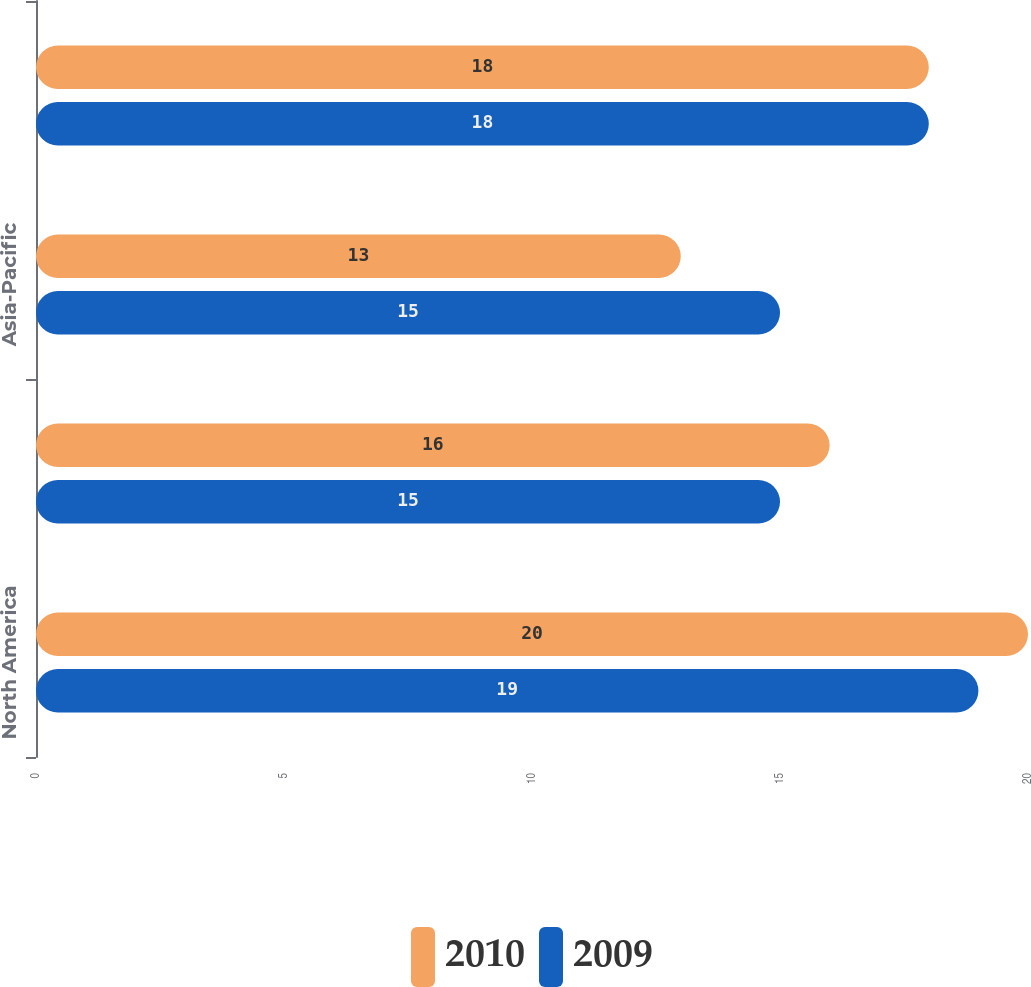Convert chart. <chart><loc_0><loc_0><loc_500><loc_500><stacked_bar_chart><ecel><fcel>North America<fcel>Europe<fcel>Asia-Pacific<fcel>Total<nl><fcel>2010<fcel>20<fcel>16<fcel>13<fcel>18<nl><fcel>2009<fcel>19<fcel>15<fcel>15<fcel>18<nl></chart> 